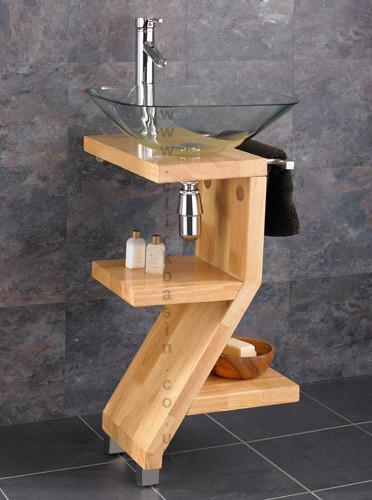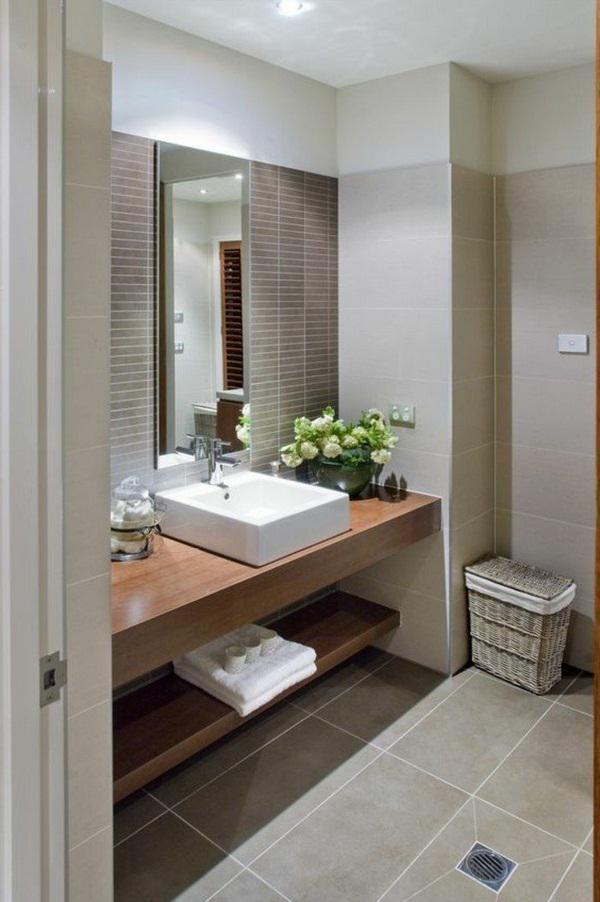The first image is the image on the left, the second image is the image on the right. For the images shown, is this caption "Photo contains single white sink." true? Answer yes or no. Yes. The first image is the image on the left, the second image is the image on the right. Given the left and right images, does the statement "One of the images shows a basin with no faucet." hold true? Answer yes or no. No. 